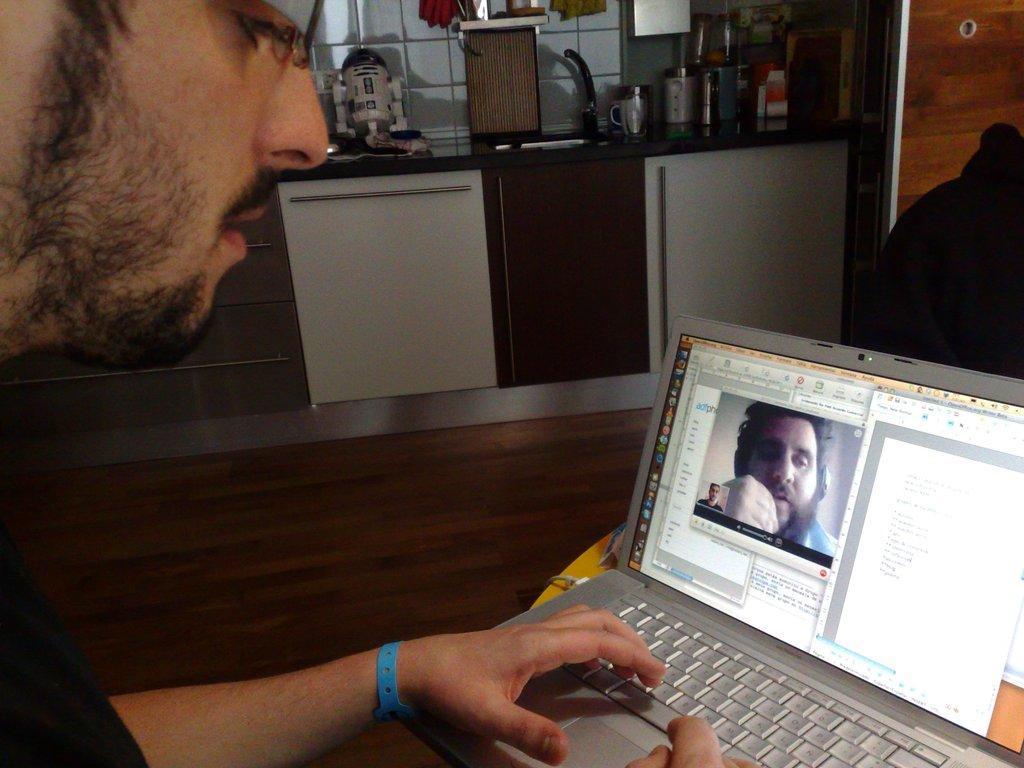Who is the main subject in the image? There is a man in the image. What is the man doing in the image? The man is looking into a laptop. Where is the laptop located in the image? The laptop is on the left side of the image. What type of wave can be seen crashing on the shore in the image? There is no wave or shore present in the image; it features a man looking into a laptop. 